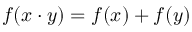<formula> <loc_0><loc_0><loc_500><loc_500>f ( x \cdot y ) = f ( x ) + f ( y )</formula> 